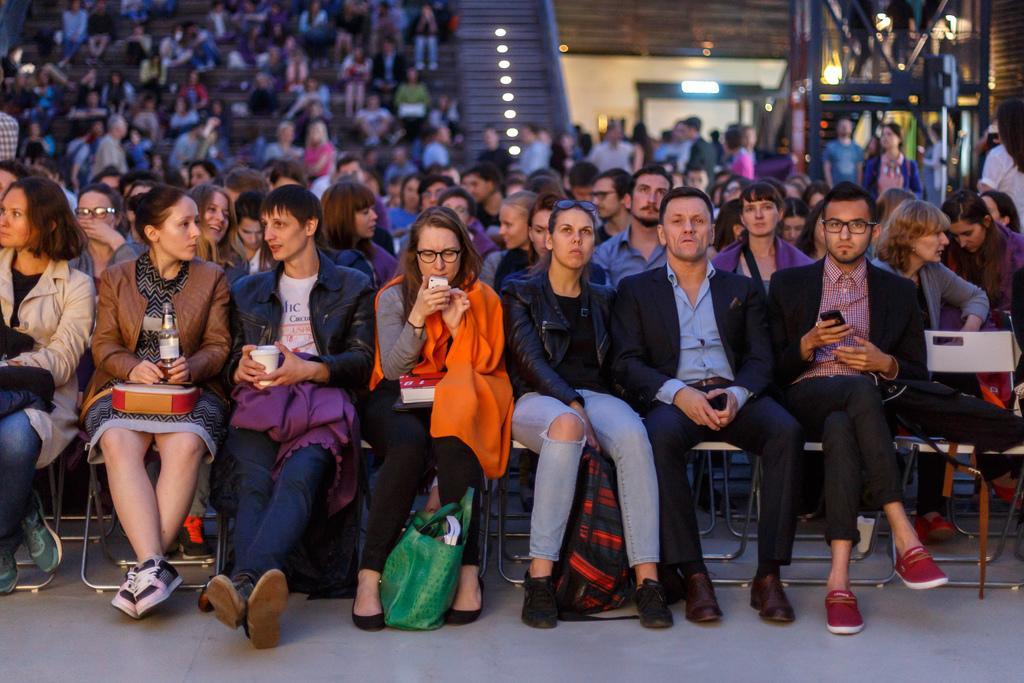Describe this image in one or two sentences. This image is taken in the auditorium. In this image there are so many people who are sitting in the chairs. At the top there are lights. There are so many people who are doing their own work. In the middle there is a girl who is sitting in the chair by holding the cup. At the bottom there is a bag. On the left side there is another woman who is sitting on the chair by holding the glass bottle and a box. On the right side there is a man who is holding the mobile. 